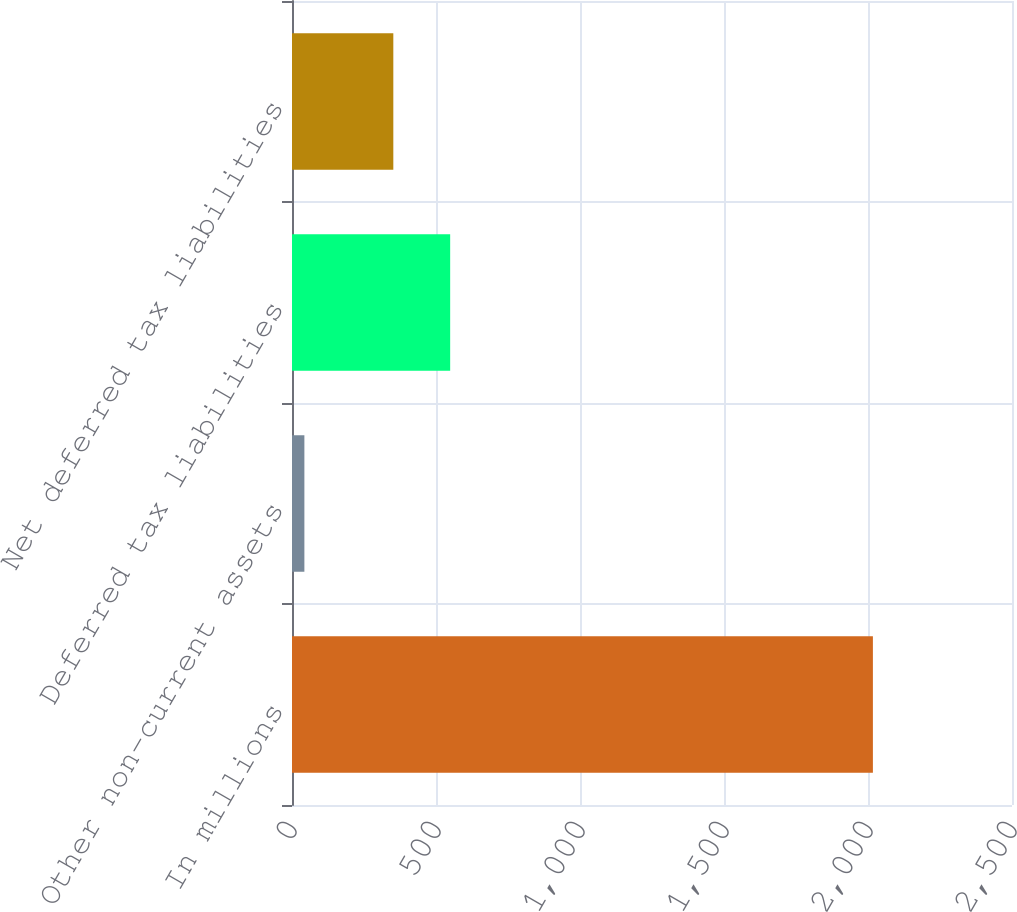Convert chart to OTSL. <chart><loc_0><loc_0><loc_500><loc_500><bar_chart><fcel>In millions<fcel>Other non-current assets<fcel>Deferred tax liabilities<fcel>Net deferred tax liabilities<nl><fcel>2017<fcel>43<fcel>549.2<fcel>351.8<nl></chart> 